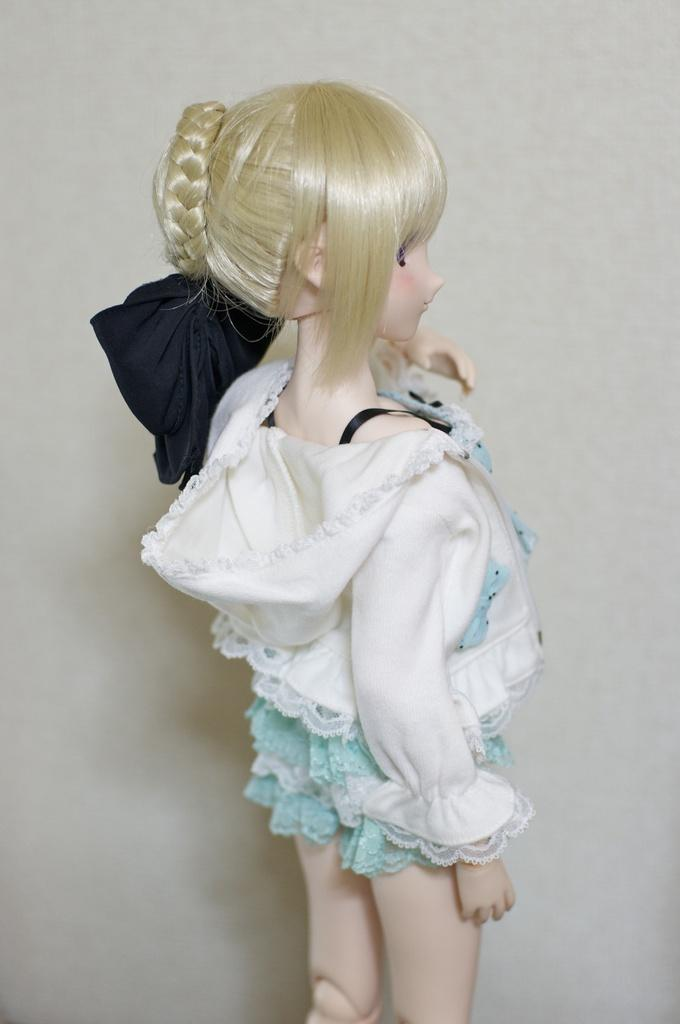What is the main subject of the image? There is a doll in the image. Can you describe the background of the image? There is a wall visible on the backside of the image. How many thumbs can be seen on the doll in the image? There is no thumb visible on the doll in the image, as it is a doll and not a human. 